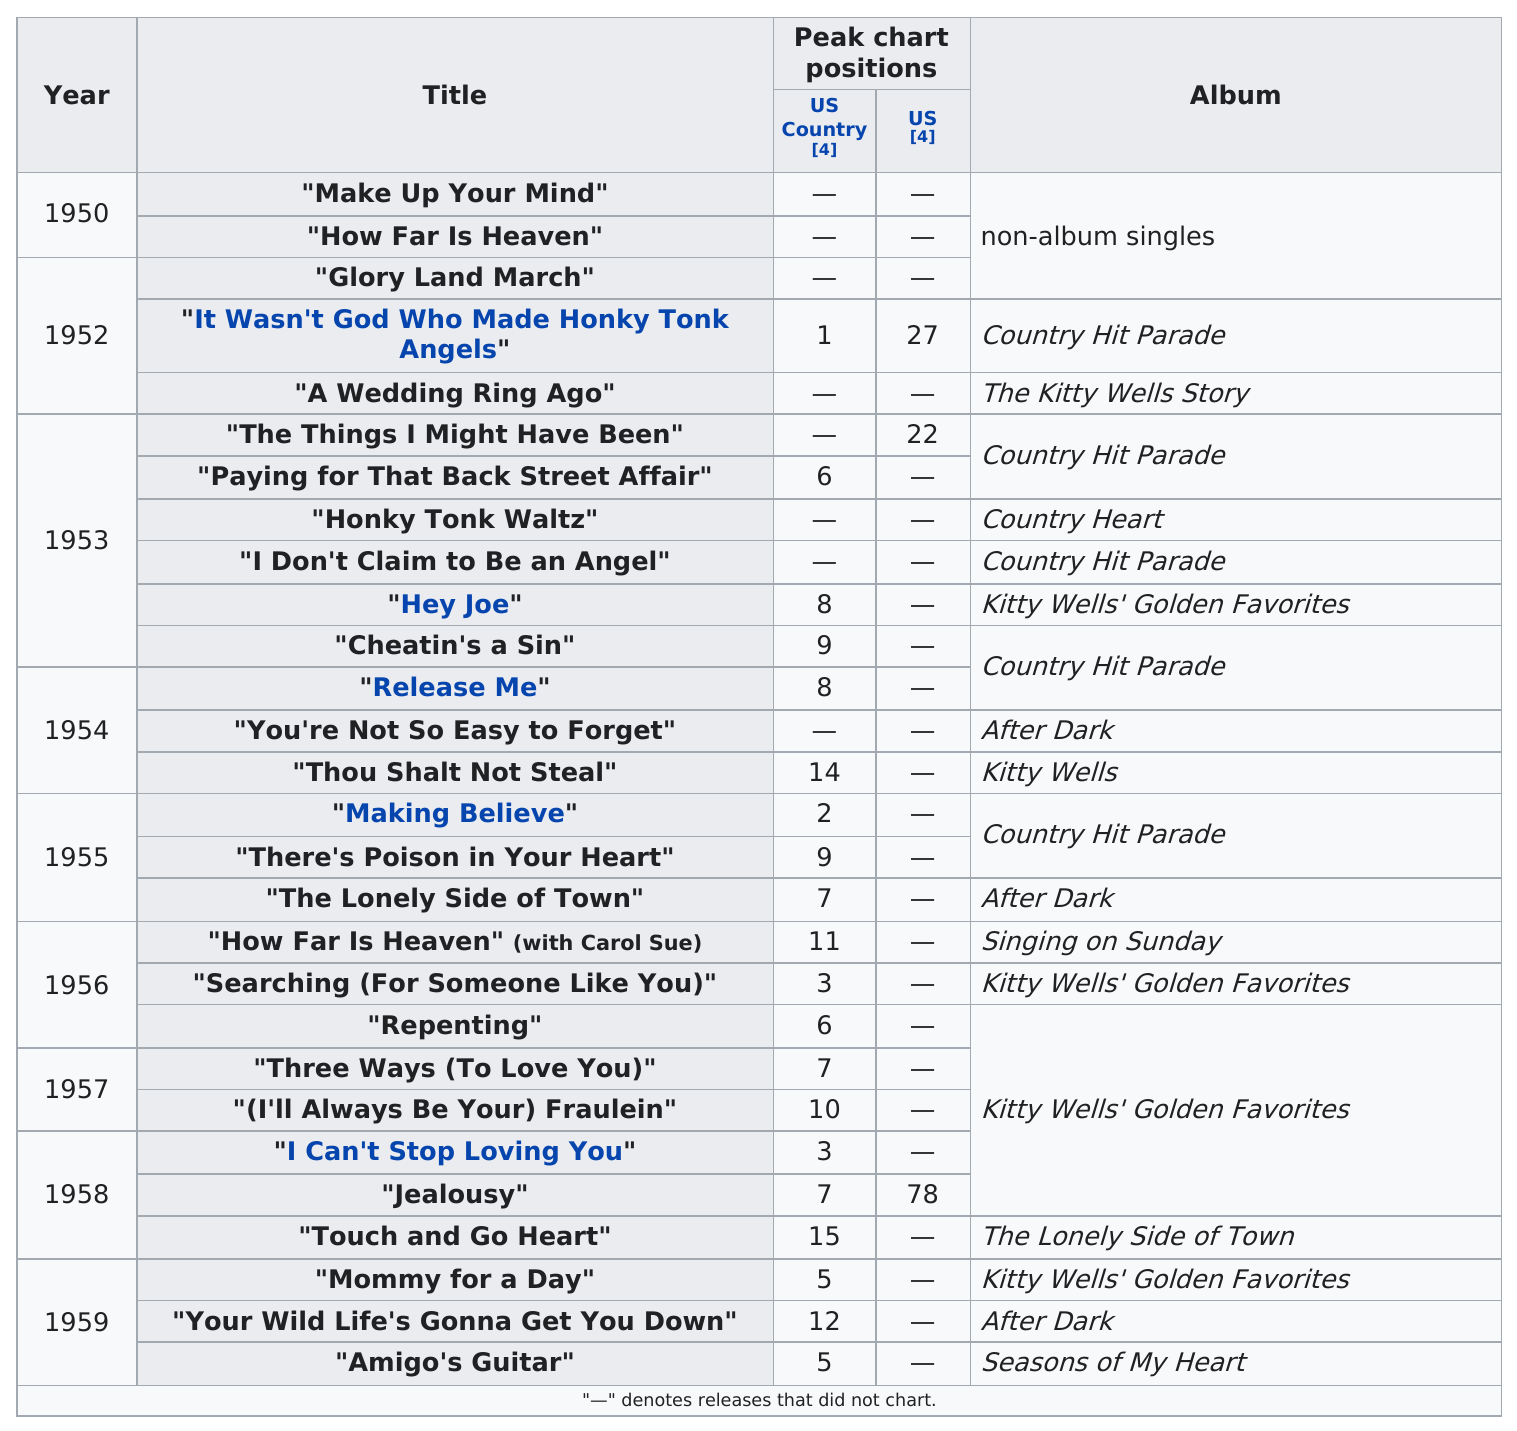Specify some key components in this picture. The last single released by Kitty Wells was "Amigo's Guitar," which was released on [date]. In 1953, country music singer Kitty Wells had three top ten hits. Of the singles that peaked above number ten on the charts, 15 of them were successful. The next album after Kitty Wells was titled "Country Hit Parade. The album that produced the most singles is Country Hit Parade. 